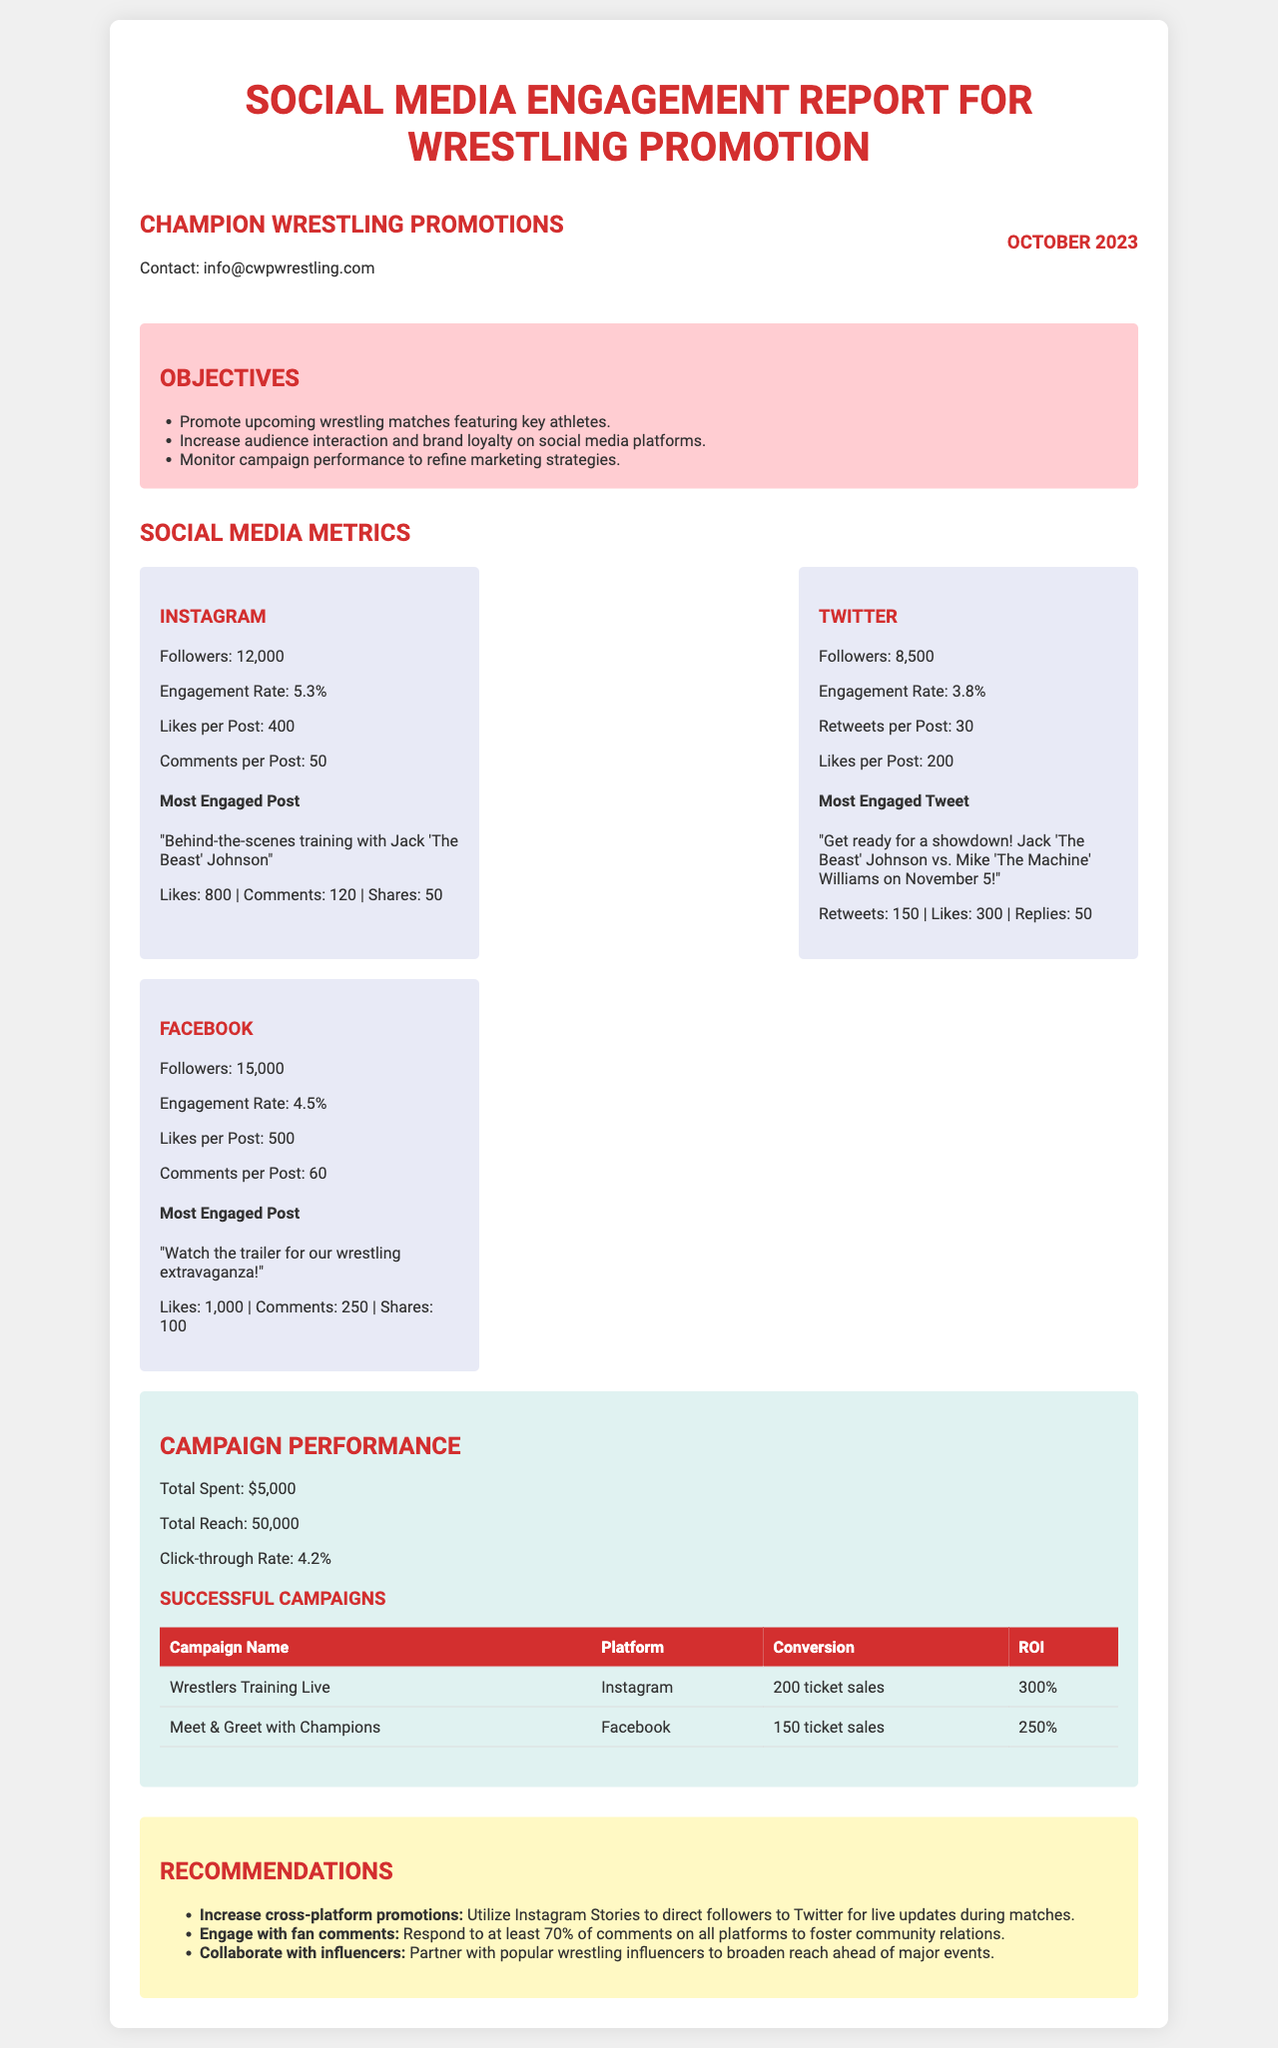What is the engagement rate on Instagram? The engagement rate on Instagram is mentioned in the metrics section.
Answer: 5.3% How many followers does Facebook have? The number of followers for Facebook is specified under the Facebook platform metrics.
Answer: 15,000 What was the total amount spent on the campaign? The total spent on the campaign is clearly stated in the campaign performance section.
Answer: $5,000 Which post had the most engagement on Twitter? The document provides the title of the most engaged tweet in the Twitter metrics section.
Answer: "Get ready for a showdown! Jack 'The Beast' Johnson vs. Mike 'The Machine' Williams on November 5!" What is the click-through rate? The click-through rate is indicated in the campaign performance section.
Answer: 4.2% Which platform had the highest total reach? The total reach is mentioned in the campaign performance section, but all platforms individually show user data.
Answer: Not specified How many ticket sales did the "Wrestlers Training Live" campaign generate? The number of ticket sales for the specific campaign is listed in the successful campaigns table.
Answer: 200 ticket sales What is a recommendation for engaging with fan comments? A specific recommendation regarding fan comments can be found in the recommendations section.
Answer: Respond to at least 70% of comments Which platform had the most followers? The followers are listed for each platform, allowing for comparison.
Answer: Facebook 